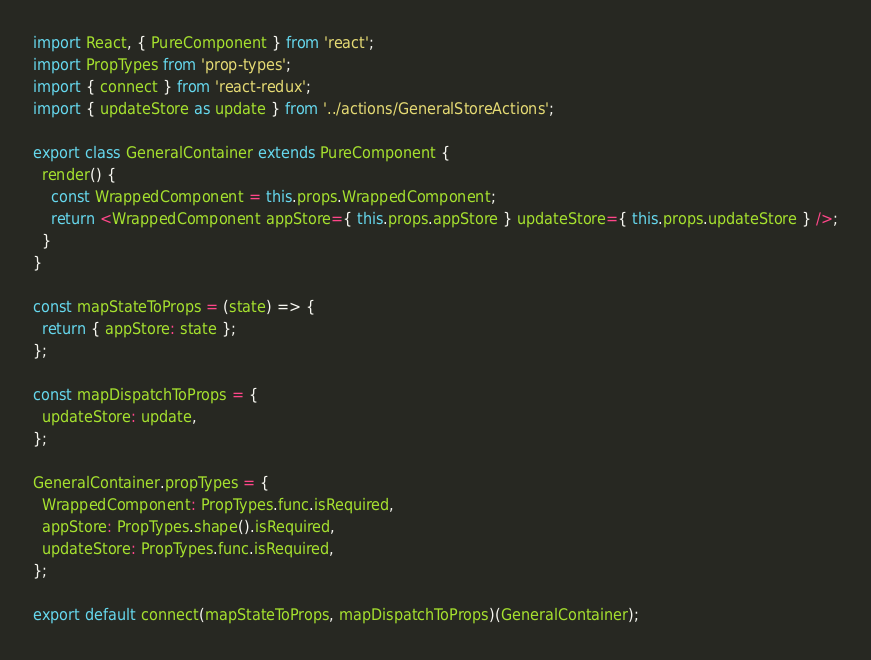<code> <loc_0><loc_0><loc_500><loc_500><_JavaScript_>import React, { PureComponent } from 'react';
import PropTypes from 'prop-types';
import { connect } from 'react-redux';
import { updateStore as update } from '../actions/GeneralStoreActions';

export class GeneralContainer extends PureComponent {
  render() {
    const WrappedComponent = this.props.WrappedComponent;
    return <WrappedComponent appStore={ this.props.appStore } updateStore={ this.props.updateStore } />;
  }
}

const mapStateToProps = (state) => {
  return { appStore: state };
};

const mapDispatchToProps = {
  updateStore: update,
};

GeneralContainer.propTypes = {
  WrappedComponent: PropTypes.func.isRequired,
  appStore: PropTypes.shape().isRequired,
  updateStore: PropTypes.func.isRequired,
};

export default connect(mapStateToProps, mapDispatchToProps)(GeneralContainer);
</code> 